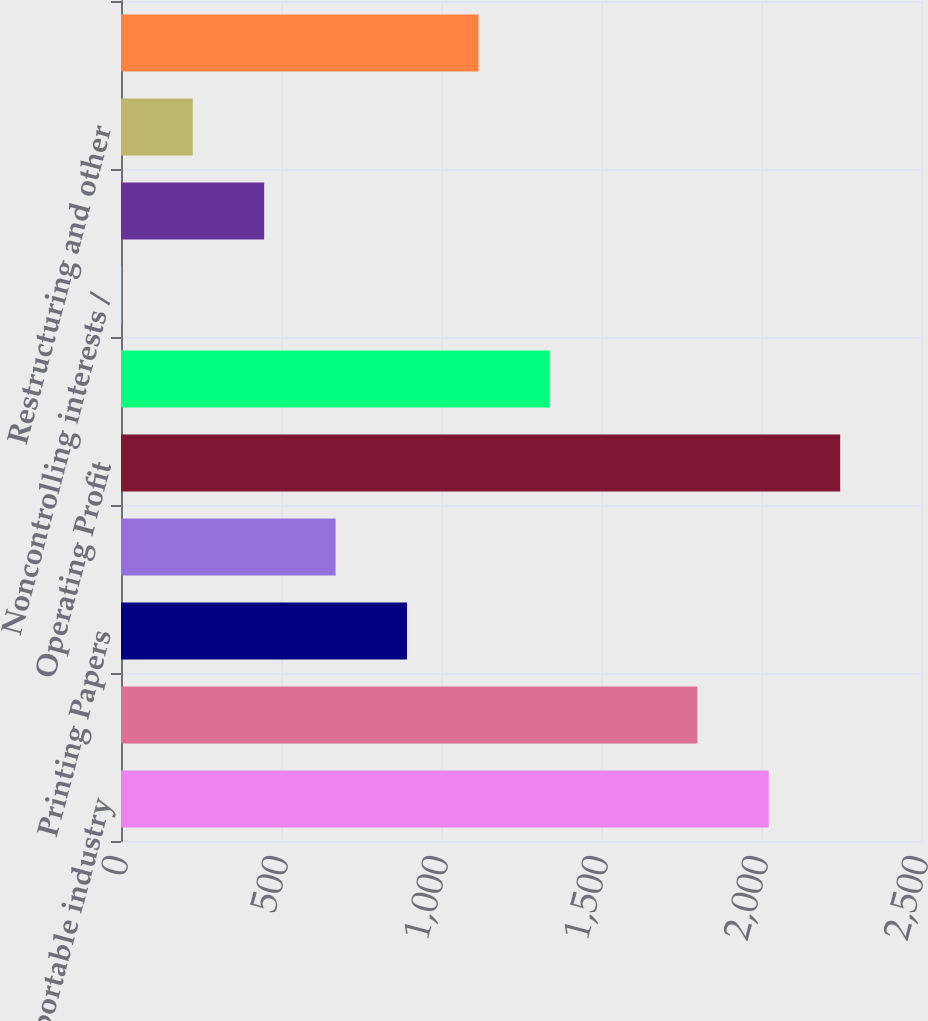<chart> <loc_0><loc_0><loc_500><loc_500><bar_chart><fcel>a separate reportable industry<fcel>Industrial Packaging<fcel>Printing Papers<fcel>Consumer Packaging<fcel>Operating Profit<fcel>Interest expense net<fcel>Noncontrolling interests /<fcel>Corporate items net<fcel>Restructuring and other<fcel>In millions 2015 2014 Current<nl><fcel>2024.2<fcel>1801<fcel>893.8<fcel>670.6<fcel>2247.4<fcel>1340.2<fcel>1<fcel>447.4<fcel>224.2<fcel>1117<nl></chart> 